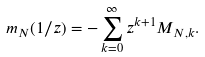Convert formula to latex. <formula><loc_0><loc_0><loc_500><loc_500>m _ { N } ( 1 / z ) & = - \sum _ { k = 0 } ^ { \infty } z ^ { k + 1 } M _ { N , k } .</formula> 